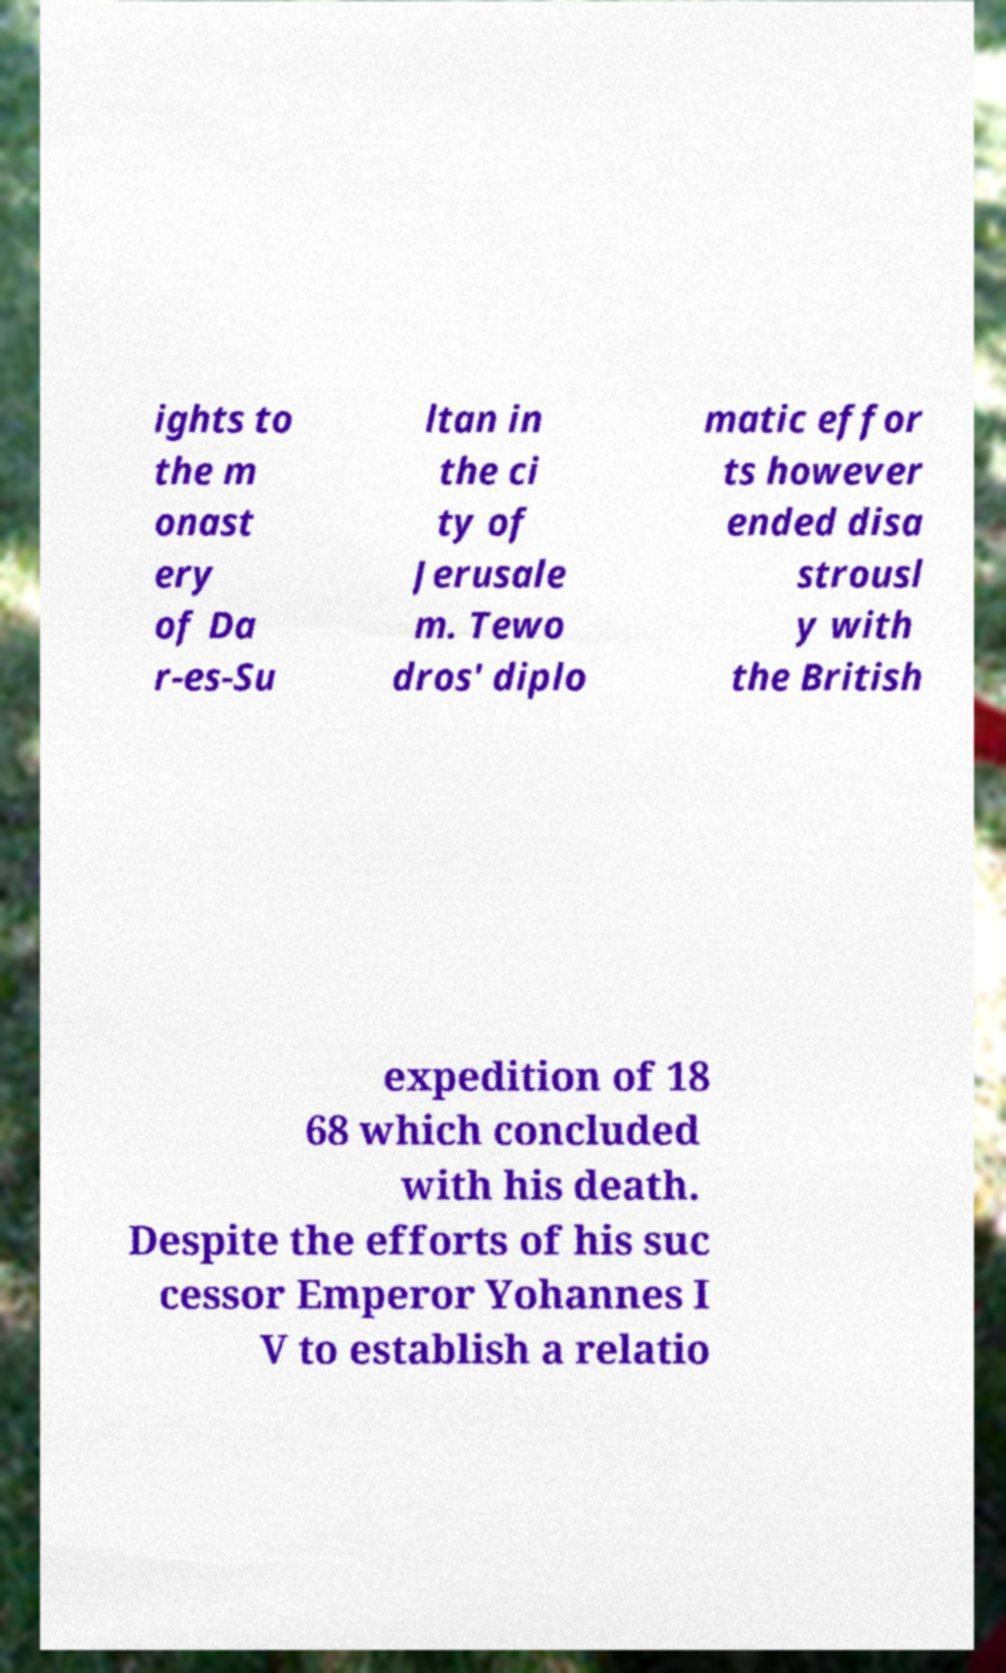Can you accurately transcribe the text from the provided image for me? ights to the m onast ery of Da r-es-Su ltan in the ci ty of Jerusale m. Tewo dros' diplo matic effor ts however ended disa strousl y with the British expedition of 18 68 which concluded with his death. Despite the efforts of his suc cessor Emperor Yohannes I V to establish a relatio 